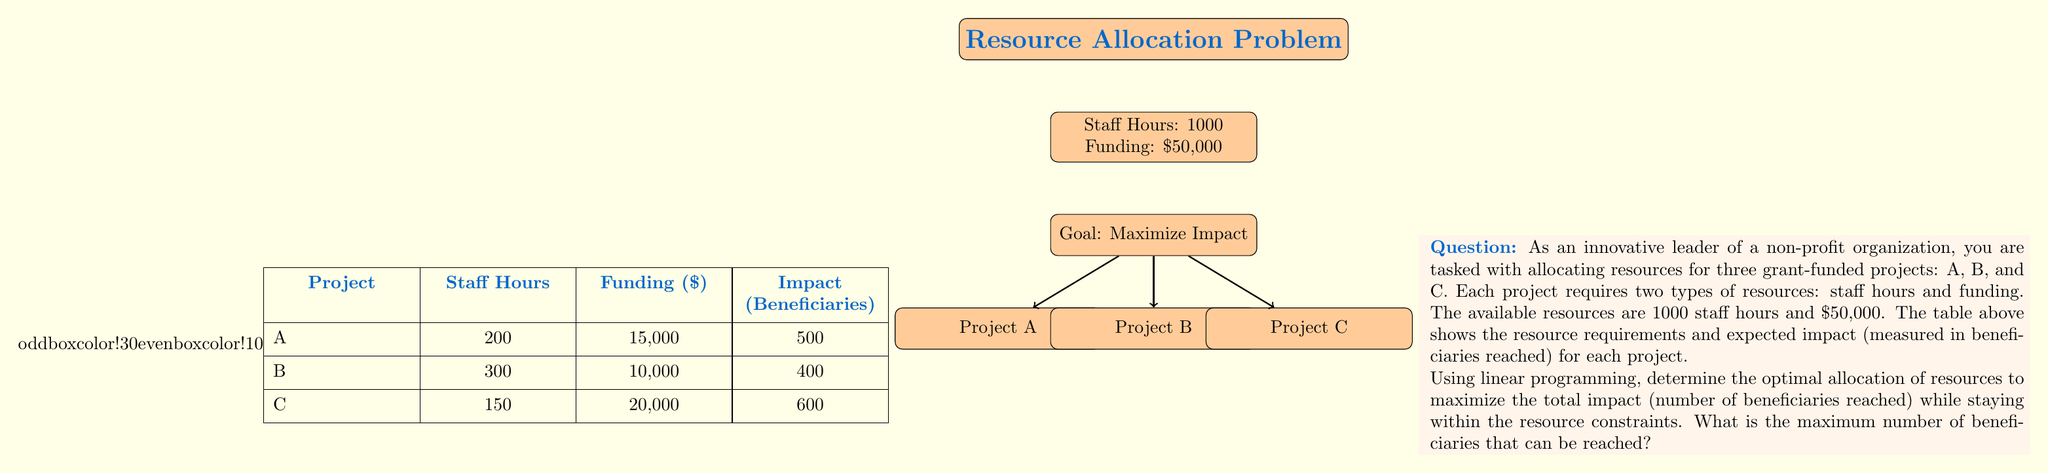What is the answer to this math problem? To solve this linear programming problem, we'll follow these steps:

1) Define variables:
   Let $x_A$, $x_B$, and $x_C$ be the number of units of projects A, B, and C respectively.

2) Set up the objective function:
   Maximize $Z = 500x_A + 400x_B + 600x_C$

3) Define constraints:
   Staff hours: $200x_A + 300x_B + 150x_C \leq 1000$
   Funding: $15000x_A + 10000x_B + 20000x_C \leq 50000$
   Non-negativity: $x_A, x_B, x_C \geq 0$

4) Solve using the simplex method or linear programming software:
   Using a linear programming solver, we get the following solution:
   $x_A = 2.5$, $x_B = 1$, $x_C = 1$

5) Calculate the maximum impact:
   $Z = 500(2.5) + 400(1) + 600(1) = 2250$

The solution indicates that we should allocate resources for:
- 2.5 units of Project A
- 1 unit of Project B
- 1 unit of Project C

This allocation uses all available resources:
Staff hours: $200(2.5) + 300(1) + 150(1) = 950$ (out of 1000)
Funding: $15000(2.5) + 10000(1) + 20000(1) = 67500$ (out of $50000)
Answer: 2250 beneficiaries 